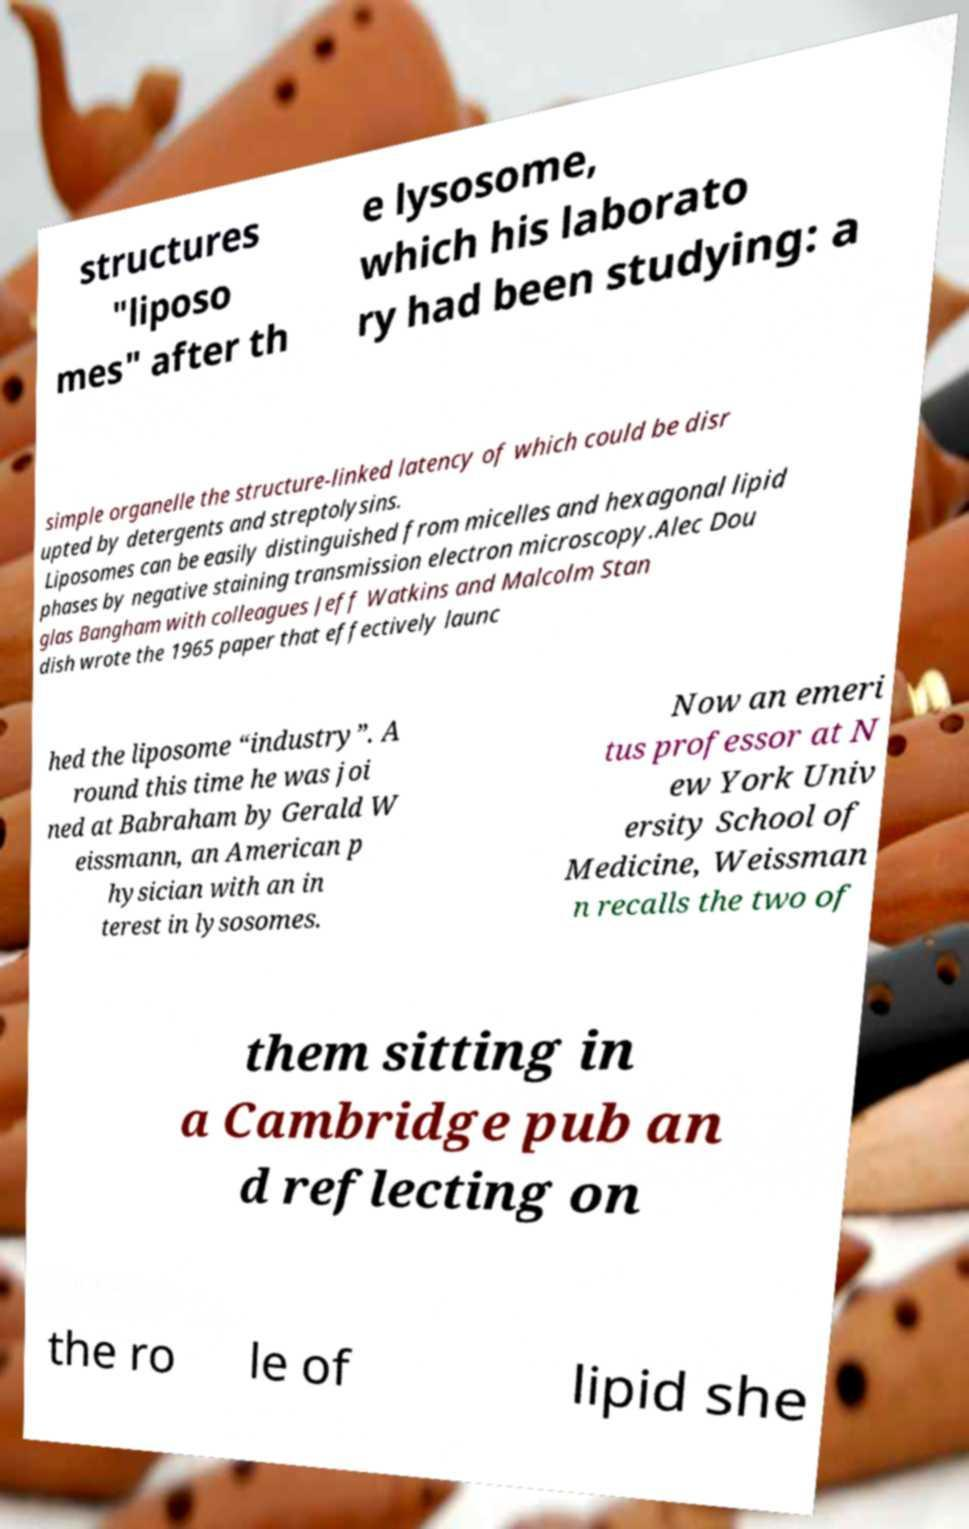Please read and relay the text visible in this image. What does it say? structures "liposo mes" after th e lysosome, which his laborato ry had been studying: a simple organelle the structure-linked latency of which could be disr upted by detergents and streptolysins. Liposomes can be easily distinguished from micelles and hexagonal lipid phases by negative staining transmission electron microscopy.Alec Dou glas Bangham with colleagues Jeff Watkins and Malcolm Stan dish wrote the 1965 paper that effectively launc hed the liposome “industry”. A round this time he was joi ned at Babraham by Gerald W eissmann, an American p hysician with an in terest in lysosomes. Now an emeri tus professor at N ew York Univ ersity School of Medicine, Weissman n recalls the two of them sitting in a Cambridge pub an d reflecting on the ro le of lipid she 